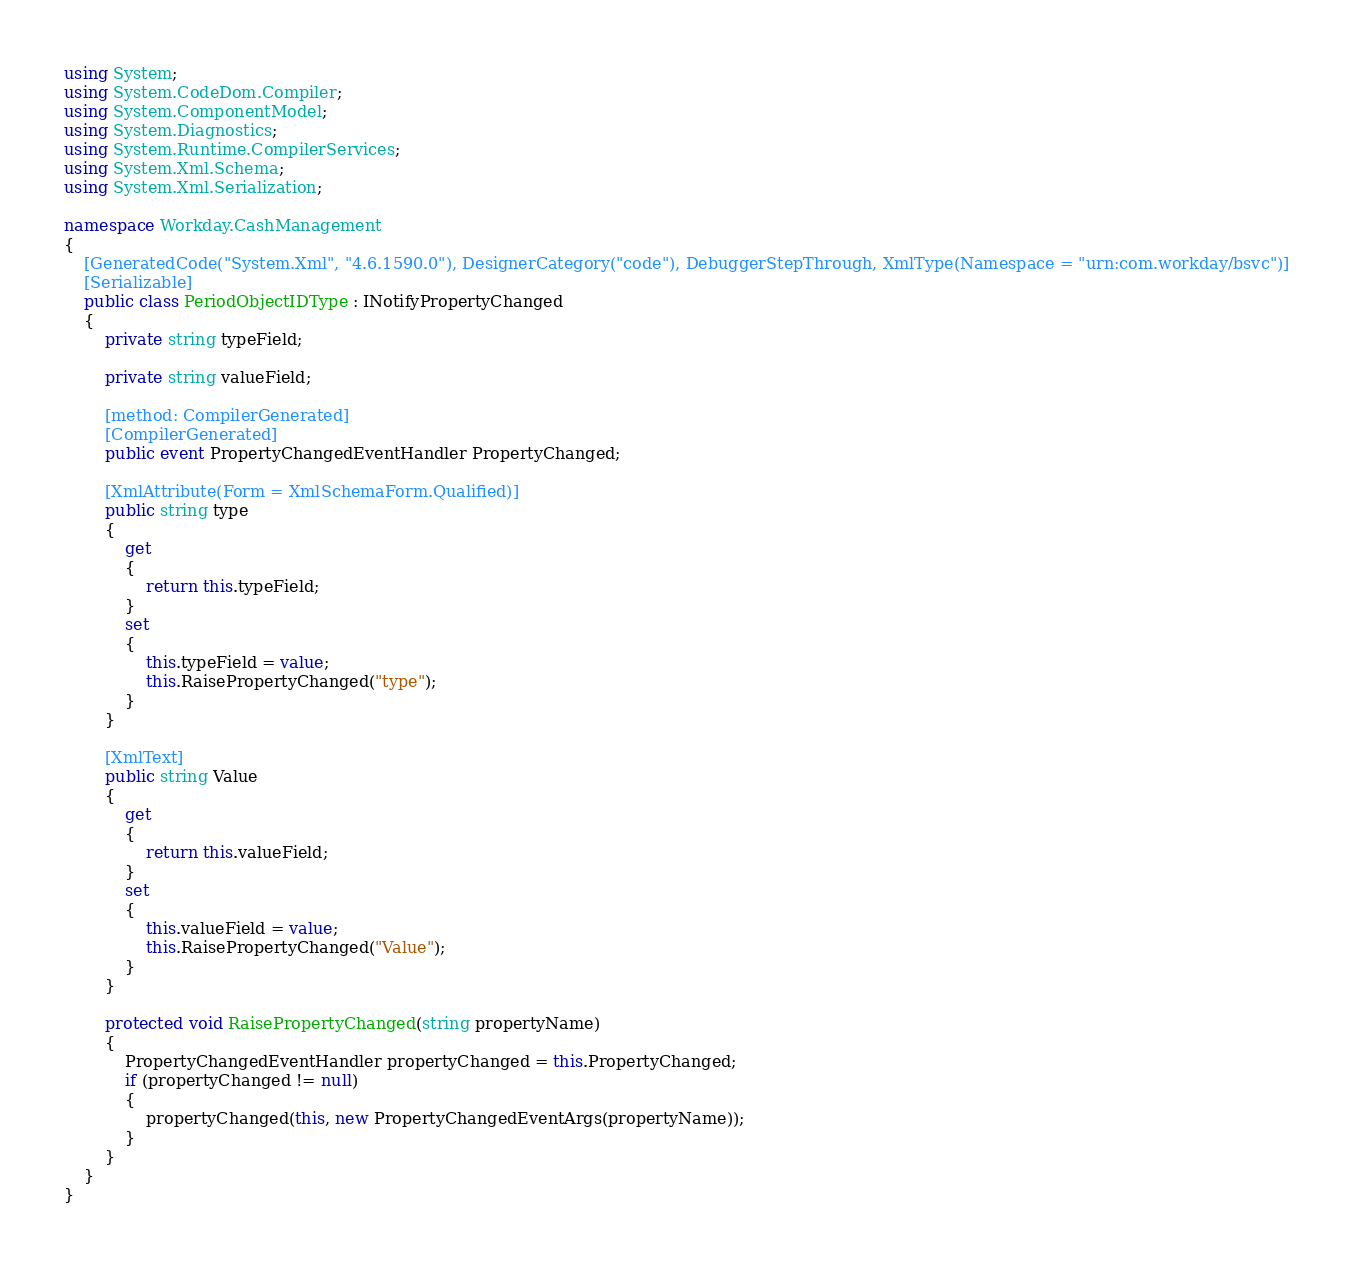Convert code to text. <code><loc_0><loc_0><loc_500><loc_500><_C#_>using System;
using System.CodeDom.Compiler;
using System.ComponentModel;
using System.Diagnostics;
using System.Runtime.CompilerServices;
using System.Xml.Schema;
using System.Xml.Serialization;

namespace Workday.CashManagement
{
	[GeneratedCode("System.Xml", "4.6.1590.0"), DesignerCategory("code"), DebuggerStepThrough, XmlType(Namespace = "urn:com.workday/bsvc")]
	[Serializable]
	public class PeriodObjectIDType : INotifyPropertyChanged
	{
		private string typeField;

		private string valueField;

		[method: CompilerGenerated]
		[CompilerGenerated]
		public event PropertyChangedEventHandler PropertyChanged;

		[XmlAttribute(Form = XmlSchemaForm.Qualified)]
		public string type
		{
			get
			{
				return this.typeField;
			}
			set
			{
				this.typeField = value;
				this.RaisePropertyChanged("type");
			}
		}

		[XmlText]
		public string Value
		{
			get
			{
				return this.valueField;
			}
			set
			{
				this.valueField = value;
				this.RaisePropertyChanged("Value");
			}
		}

		protected void RaisePropertyChanged(string propertyName)
		{
			PropertyChangedEventHandler propertyChanged = this.PropertyChanged;
			if (propertyChanged != null)
			{
				propertyChanged(this, new PropertyChangedEventArgs(propertyName));
			}
		}
	}
}
</code> 